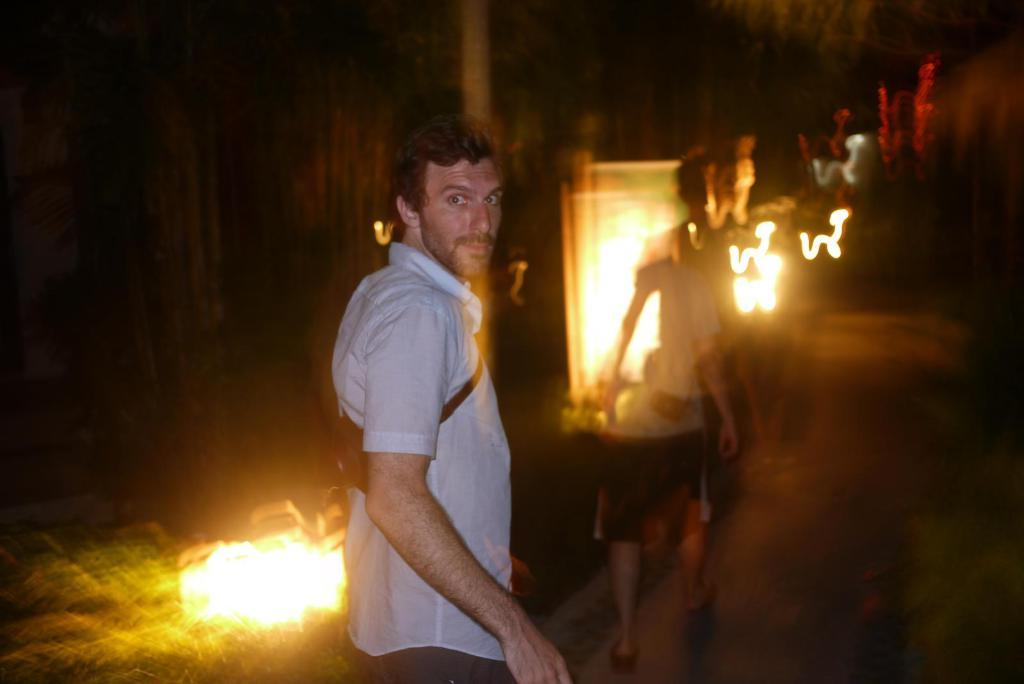How many people are in the image? There are two persons in the image. What are the persons doing in the image? The persons are standing on the ground. Can you describe the attire of one of the persons? One person is wearing a bag. What can be seen in the background of the image? There are lights visible in the background of the image. Are the two persons in the image brothers? There is no information provided about the relationship between the two persons in the image, so we cannot determine if they are brothers. Can you see any horses in the image? There are no horses present in the image. 